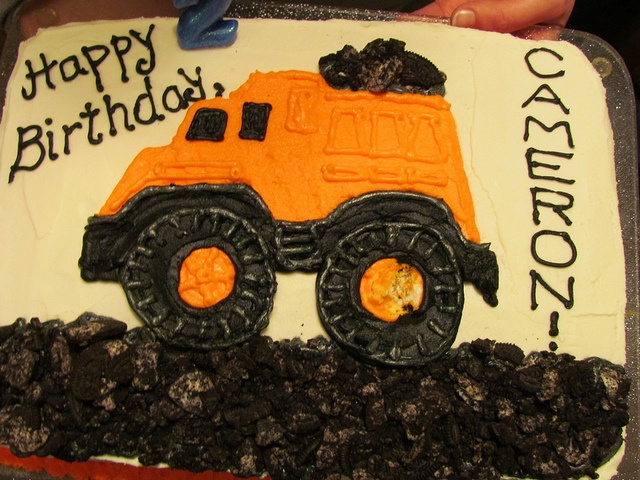Describe the objects in this image and their specific colors. I can see cake in black, khaki, and orange tones, truck in black, orange, and darkgreen tones, and people in black, maroon, brown, and red tones in this image. 